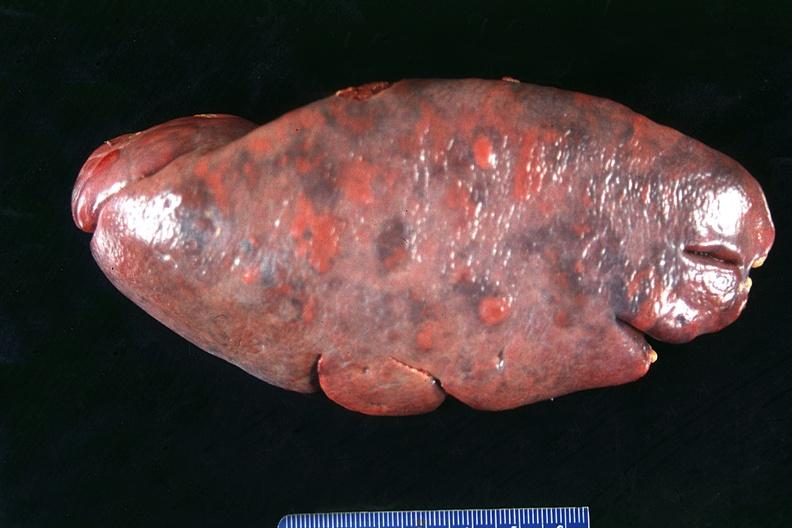s hemorrhagic corpus luteum present?
Answer the question using a single word or phrase. No 